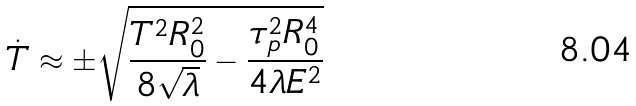Convert formula to latex. <formula><loc_0><loc_0><loc_500><loc_500>\dot { T } \approx \pm \sqrt { \frac { T ^ { 2 } R _ { 0 } ^ { 2 } } { 8 \sqrt { \lambda } } - \frac { \tau _ { p } ^ { 2 } R _ { 0 } ^ { 4 } } { 4 \lambda E ^ { 2 } } }</formula> 